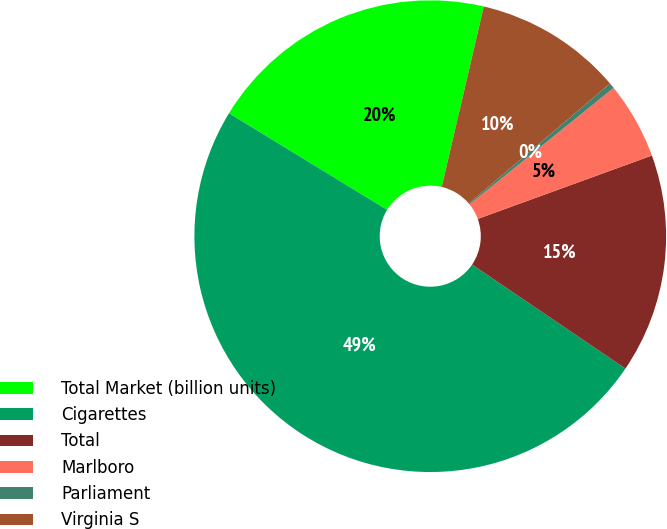Convert chart. <chart><loc_0><loc_0><loc_500><loc_500><pie_chart><fcel>Total Market (billion units)<fcel>Cigarettes<fcel>Total<fcel>Marlboro<fcel>Parliament<fcel>Virginia S<nl><fcel>19.92%<fcel>49.24%<fcel>15.04%<fcel>5.27%<fcel>0.38%<fcel>10.15%<nl></chart> 